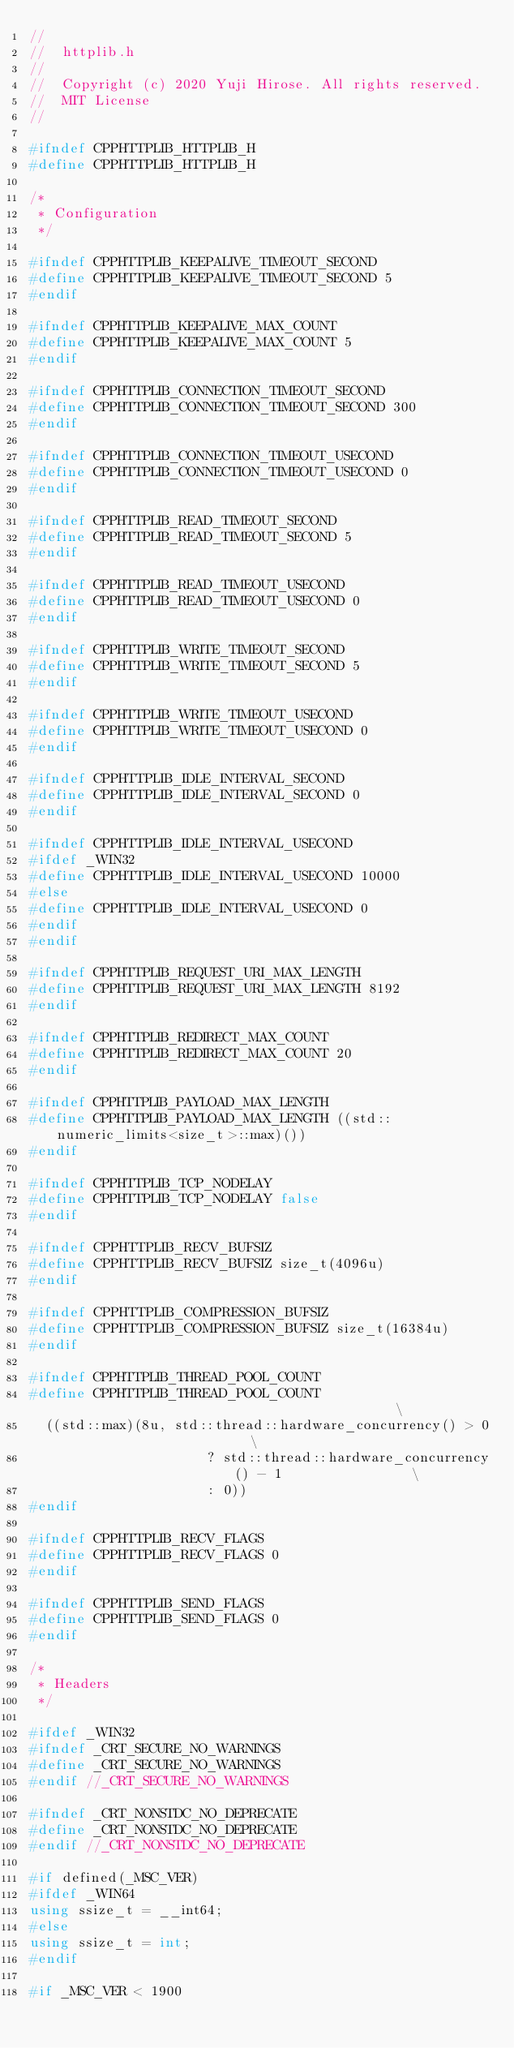Convert code to text. <code><loc_0><loc_0><loc_500><loc_500><_C++_>//
//  httplib.h
//
//  Copyright (c) 2020 Yuji Hirose. All rights reserved.
//  MIT License
//

#ifndef CPPHTTPLIB_HTTPLIB_H
#define CPPHTTPLIB_HTTPLIB_H

/*
 * Configuration
 */

#ifndef CPPHTTPLIB_KEEPALIVE_TIMEOUT_SECOND
#define CPPHTTPLIB_KEEPALIVE_TIMEOUT_SECOND 5
#endif

#ifndef CPPHTTPLIB_KEEPALIVE_MAX_COUNT
#define CPPHTTPLIB_KEEPALIVE_MAX_COUNT 5
#endif

#ifndef CPPHTTPLIB_CONNECTION_TIMEOUT_SECOND
#define CPPHTTPLIB_CONNECTION_TIMEOUT_SECOND 300
#endif

#ifndef CPPHTTPLIB_CONNECTION_TIMEOUT_USECOND
#define CPPHTTPLIB_CONNECTION_TIMEOUT_USECOND 0
#endif

#ifndef CPPHTTPLIB_READ_TIMEOUT_SECOND
#define CPPHTTPLIB_READ_TIMEOUT_SECOND 5
#endif

#ifndef CPPHTTPLIB_READ_TIMEOUT_USECOND
#define CPPHTTPLIB_READ_TIMEOUT_USECOND 0
#endif

#ifndef CPPHTTPLIB_WRITE_TIMEOUT_SECOND
#define CPPHTTPLIB_WRITE_TIMEOUT_SECOND 5
#endif

#ifndef CPPHTTPLIB_WRITE_TIMEOUT_USECOND
#define CPPHTTPLIB_WRITE_TIMEOUT_USECOND 0
#endif

#ifndef CPPHTTPLIB_IDLE_INTERVAL_SECOND
#define CPPHTTPLIB_IDLE_INTERVAL_SECOND 0
#endif

#ifndef CPPHTTPLIB_IDLE_INTERVAL_USECOND
#ifdef _WIN32
#define CPPHTTPLIB_IDLE_INTERVAL_USECOND 10000
#else
#define CPPHTTPLIB_IDLE_INTERVAL_USECOND 0
#endif
#endif

#ifndef CPPHTTPLIB_REQUEST_URI_MAX_LENGTH
#define CPPHTTPLIB_REQUEST_URI_MAX_LENGTH 8192
#endif

#ifndef CPPHTTPLIB_REDIRECT_MAX_COUNT
#define CPPHTTPLIB_REDIRECT_MAX_COUNT 20
#endif

#ifndef CPPHTTPLIB_PAYLOAD_MAX_LENGTH
#define CPPHTTPLIB_PAYLOAD_MAX_LENGTH ((std::numeric_limits<size_t>::max)())
#endif

#ifndef CPPHTTPLIB_TCP_NODELAY
#define CPPHTTPLIB_TCP_NODELAY false
#endif

#ifndef CPPHTTPLIB_RECV_BUFSIZ
#define CPPHTTPLIB_RECV_BUFSIZ size_t(4096u)
#endif

#ifndef CPPHTTPLIB_COMPRESSION_BUFSIZ
#define CPPHTTPLIB_COMPRESSION_BUFSIZ size_t(16384u)
#endif

#ifndef CPPHTTPLIB_THREAD_POOL_COUNT
#define CPPHTTPLIB_THREAD_POOL_COUNT                                           \
  ((std::max)(8u, std::thread::hardware_concurrency() > 0                      \
                      ? std::thread::hardware_concurrency() - 1                \
                      : 0))
#endif

#ifndef CPPHTTPLIB_RECV_FLAGS
#define CPPHTTPLIB_RECV_FLAGS 0
#endif

#ifndef CPPHTTPLIB_SEND_FLAGS
#define CPPHTTPLIB_SEND_FLAGS 0
#endif

/*
 * Headers
 */

#ifdef _WIN32
#ifndef _CRT_SECURE_NO_WARNINGS
#define _CRT_SECURE_NO_WARNINGS
#endif //_CRT_SECURE_NO_WARNINGS

#ifndef _CRT_NONSTDC_NO_DEPRECATE
#define _CRT_NONSTDC_NO_DEPRECATE
#endif //_CRT_NONSTDC_NO_DEPRECATE

#if defined(_MSC_VER)
#ifdef _WIN64
using ssize_t = __int64;
#else
using ssize_t = int;
#endif

#if _MSC_VER < 1900</code> 